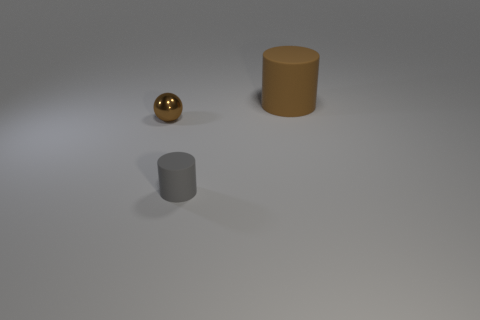Is there any other thing that has the same material as the brown sphere?
Your answer should be very brief. No. There is a small object that is the same shape as the large brown matte thing; what material is it?
Your response must be concise. Rubber. What color is the thing that is to the left of the big matte object and behind the tiny gray thing?
Your answer should be compact. Brown. What is the color of the tiny rubber cylinder?
Your response must be concise. Gray. There is a ball that is the same color as the large cylinder; what material is it?
Your answer should be very brief. Metal. Are there any brown objects of the same shape as the gray thing?
Your response must be concise. Yes. What is the size of the thing that is in front of the tiny shiny sphere?
Offer a terse response. Small. What material is the ball that is the same size as the gray matte thing?
Ensure brevity in your answer.  Metal. Are there more tiny yellow shiny things than brown cylinders?
Your answer should be very brief. No. There is a brown object to the right of the tiny thing that is behind the tiny gray cylinder; what is its size?
Keep it short and to the point. Large. 